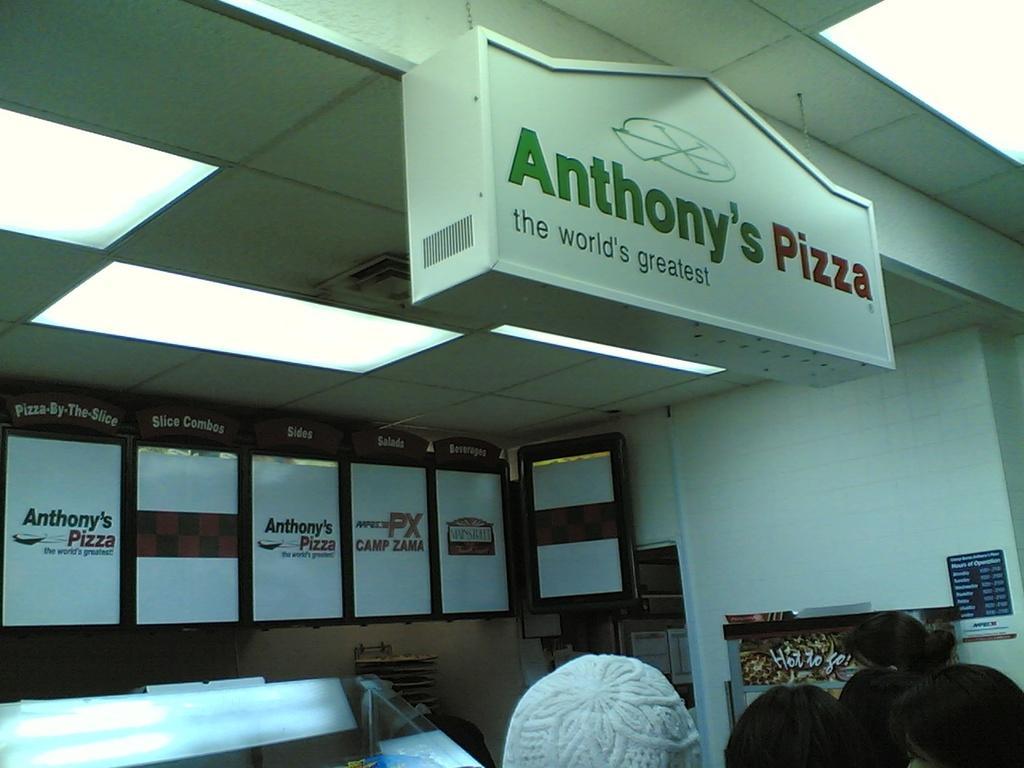How would you summarize this image in a sentence or two? In the foreground of this image, at the bottom, there are heads of person. In the background, there is a wall, few boards and the lights to the ceiling. 